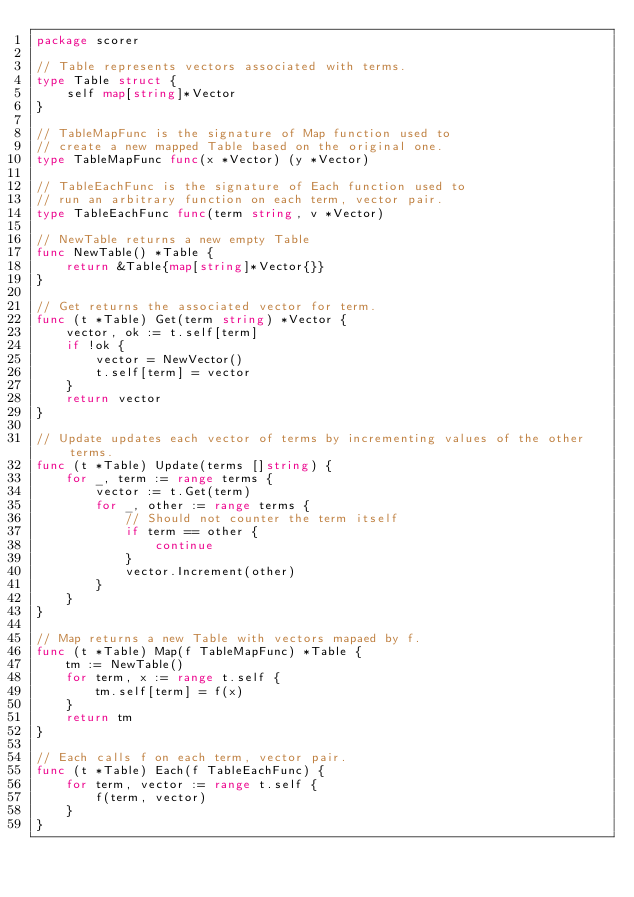Convert code to text. <code><loc_0><loc_0><loc_500><loc_500><_Go_>package scorer

// Table represents vectors associated with terms.
type Table struct {
	self map[string]*Vector
}

// TableMapFunc is the signature of Map function used to
// create a new mapped Table based on the original one.
type TableMapFunc func(x *Vector) (y *Vector)

// TableEachFunc is the signature of Each function used to
// run an arbitrary function on each term, vector pair.
type TableEachFunc func(term string, v *Vector)

// NewTable returns a new empty Table
func NewTable() *Table {
	return &Table{map[string]*Vector{}}
}

// Get returns the associated vector for term.
func (t *Table) Get(term string) *Vector {
	vector, ok := t.self[term]
	if !ok {
		vector = NewVector()
		t.self[term] = vector
	}
	return vector
}

// Update updates each vector of terms by incrementing values of the other terms.
func (t *Table) Update(terms []string) {
	for _, term := range terms {
		vector := t.Get(term)
		for _, other := range terms {
			// Should not counter the term itself
			if term == other {
				continue
			}
			vector.Increment(other)
		}
	}
}

// Map returns a new Table with vectors mapaed by f.
func (t *Table) Map(f TableMapFunc) *Table {
	tm := NewTable()
	for term, x := range t.self {
		tm.self[term] = f(x)
	}
	return tm
}

// Each calls f on each term, vector pair.
func (t *Table) Each(f TableEachFunc) {
	for term, vector := range t.self {
		f(term, vector)
	}
}
</code> 